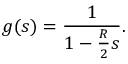Convert formula to latex. <formula><loc_0><loc_0><loc_500><loc_500>g ( s ) = \frac { 1 } { 1 - \frac { R } { 2 } s } .</formula> 